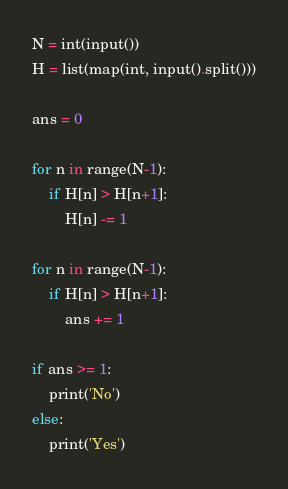Convert code to text. <code><loc_0><loc_0><loc_500><loc_500><_Python_>N = int(input())
H = list(map(int, input().split()))

ans = 0

for n in range(N-1):
    if H[n] > H[n+1]:
        H[n] -= 1

for n in range(N-1):
    if H[n] > H[n+1]:
        ans += 1

if ans >= 1:
    print('No')
else:
    print('Yes')</code> 